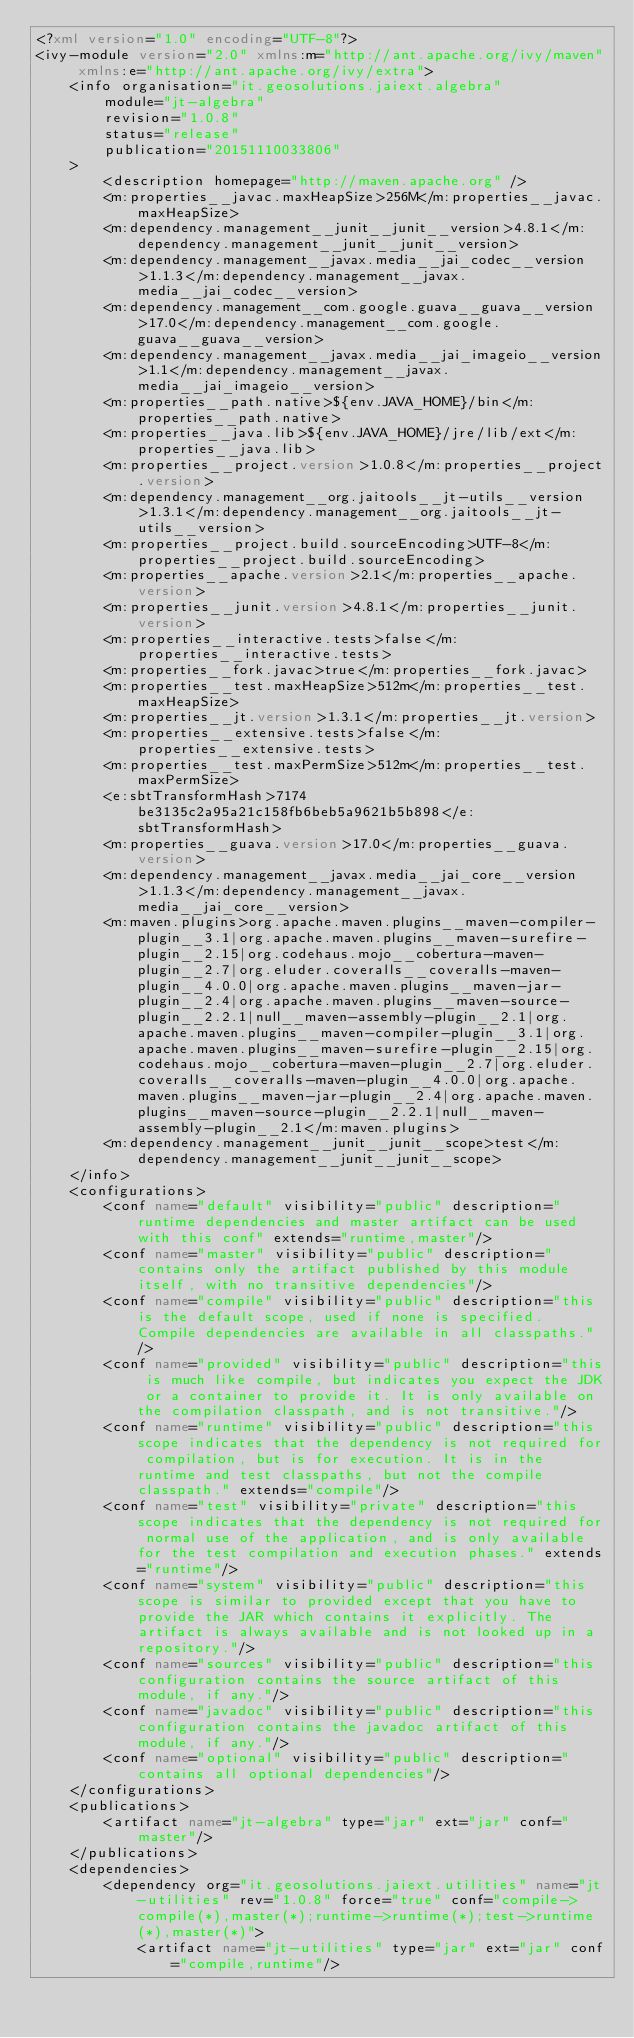Convert code to text. <code><loc_0><loc_0><loc_500><loc_500><_XML_><?xml version="1.0" encoding="UTF-8"?>
<ivy-module version="2.0" xmlns:m="http://ant.apache.org/ivy/maven" xmlns:e="http://ant.apache.org/ivy/extra">
	<info organisation="it.geosolutions.jaiext.algebra"
		module="jt-algebra"
		revision="1.0.8"
		status="release"
		publication="20151110033806"
	>
		<description homepage="http://maven.apache.org" />
		<m:properties__javac.maxHeapSize>256M</m:properties__javac.maxHeapSize>
		<m:dependency.management__junit__junit__version>4.8.1</m:dependency.management__junit__junit__version>
		<m:dependency.management__javax.media__jai_codec__version>1.1.3</m:dependency.management__javax.media__jai_codec__version>
		<m:dependency.management__com.google.guava__guava__version>17.0</m:dependency.management__com.google.guava__guava__version>
		<m:dependency.management__javax.media__jai_imageio__version>1.1</m:dependency.management__javax.media__jai_imageio__version>
		<m:properties__path.native>${env.JAVA_HOME}/bin</m:properties__path.native>
		<m:properties__java.lib>${env.JAVA_HOME}/jre/lib/ext</m:properties__java.lib>
		<m:properties__project.version>1.0.8</m:properties__project.version>
		<m:dependency.management__org.jaitools__jt-utils__version>1.3.1</m:dependency.management__org.jaitools__jt-utils__version>
		<m:properties__project.build.sourceEncoding>UTF-8</m:properties__project.build.sourceEncoding>
		<m:properties__apache.version>2.1</m:properties__apache.version>
		<m:properties__junit.version>4.8.1</m:properties__junit.version>
		<m:properties__interactive.tests>false</m:properties__interactive.tests>
		<m:properties__fork.javac>true</m:properties__fork.javac>
		<m:properties__test.maxHeapSize>512m</m:properties__test.maxHeapSize>
		<m:properties__jt.version>1.3.1</m:properties__jt.version>
		<m:properties__extensive.tests>false</m:properties__extensive.tests>
		<m:properties__test.maxPermSize>512m</m:properties__test.maxPermSize>
		<e:sbtTransformHash>7174be3135c2a95a21c158fb6beb5a9621b5b898</e:sbtTransformHash>
		<m:properties__guava.version>17.0</m:properties__guava.version>
		<m:dependency.management__javax.media__jai_core__version>1.1.3</m:dependency.management__javax.media__jai_core__version>
		<m:maven.plugins>org.apache.maven.plugins__maven-compiler-plugin__3.1|org.apache.maven.plugins__maven-surefire-plugin__2.15|org.codehaus.mojo__cobertura-maven-plugin__2.7|org.eluder.coveralls__coveralls-maven-plugin__4.0.0|org.apache.maven.plugins__maven-jar-plugin__2.4|org.apache.maven.plugins__maven-source-plugin__2.2.1|null__maven-assembly-plugin__2.1|org.apache.maven.plugins__maven-compiler-plugin__3.1|org.apache.maven.plugins__maven-surefire-plugin__2.15|org.codehaus.mojo__cobertura-maven-plugin__2.7|org.eluder.coveralls__coveralls-maven-plugin__4.0.0|org.apache.maven.plugins__maven-jar-plugin__2.4|org.apache.maven.plugins__maven-source-plugin__2.2.1|null__maven-assembly-plugin__2.1</m:maven.plugins>
		<m:dependency.management__junit__junit__scope>test</m:dependency.management__junit__junit__scope>
	</info>
	<configurations>
		<conf name="default" visibility="public" description="runtime dependencies and master artifact can be used with this conf" extends="runtime,master"/>
		<conf name="master" visibility="public" description="contains only the artifact published by this module itself, with no transitive dependencies"/>
		<conf name="compile" visibility="public" description="this is the default scope, used if none is specified. Compile dependencies are available in all classpaths."/>
		<conf name="provided" visibility="public" description="this is much like compile, but indicates you expect the JDK or a container to provide it. It is only available on the compilation classpath, and is not transitive."/>
		<conf name="runtime" visibility="public" description="this scope indicates that the dependency is not required for compilation, but is for execution. It is in the runtime and test classpaths, but not the compile classpath." extends="compile"/>
		<conf name="test" visibility="private" description="this scope indicates that the dependency is not required for normal use of the application, and is only available for the test compilation and execution phases." extends="runtime"/>
		<conf name="system" visibility="public" description="this scope is similar to provided except that you have to provide the JAR which contains it explicitly. The artifact is always available and is not looked up in a repository."/>
		<conf name="sources" visibility="public" description="this configuration contains the source artifact of this module, if any."/>
		<conf name="javadoc" visibility="public" description="this configuration contains the javadoc artifact of this module, if any."/>
		<conf name="optional" visibility="public" description="contains all optional dependencies"/>
	</configurations>
	<publications>
		<artifact name="jt-algebra" type="jar" ext="jar" conf="master"/>
	</publications>
	<dependencies>
		<dependency org="it.geosolutions.jaiext.utilities" name="jt-utilities" rev="1.0.8" force="true" conf="compile->compile(*),master(*);runtime->runtime(*);test->runtime(*),master(*)">
			<artifact name="jt-utilities" type="jar" ext="jar" conf="compile,runtime"/></code> 